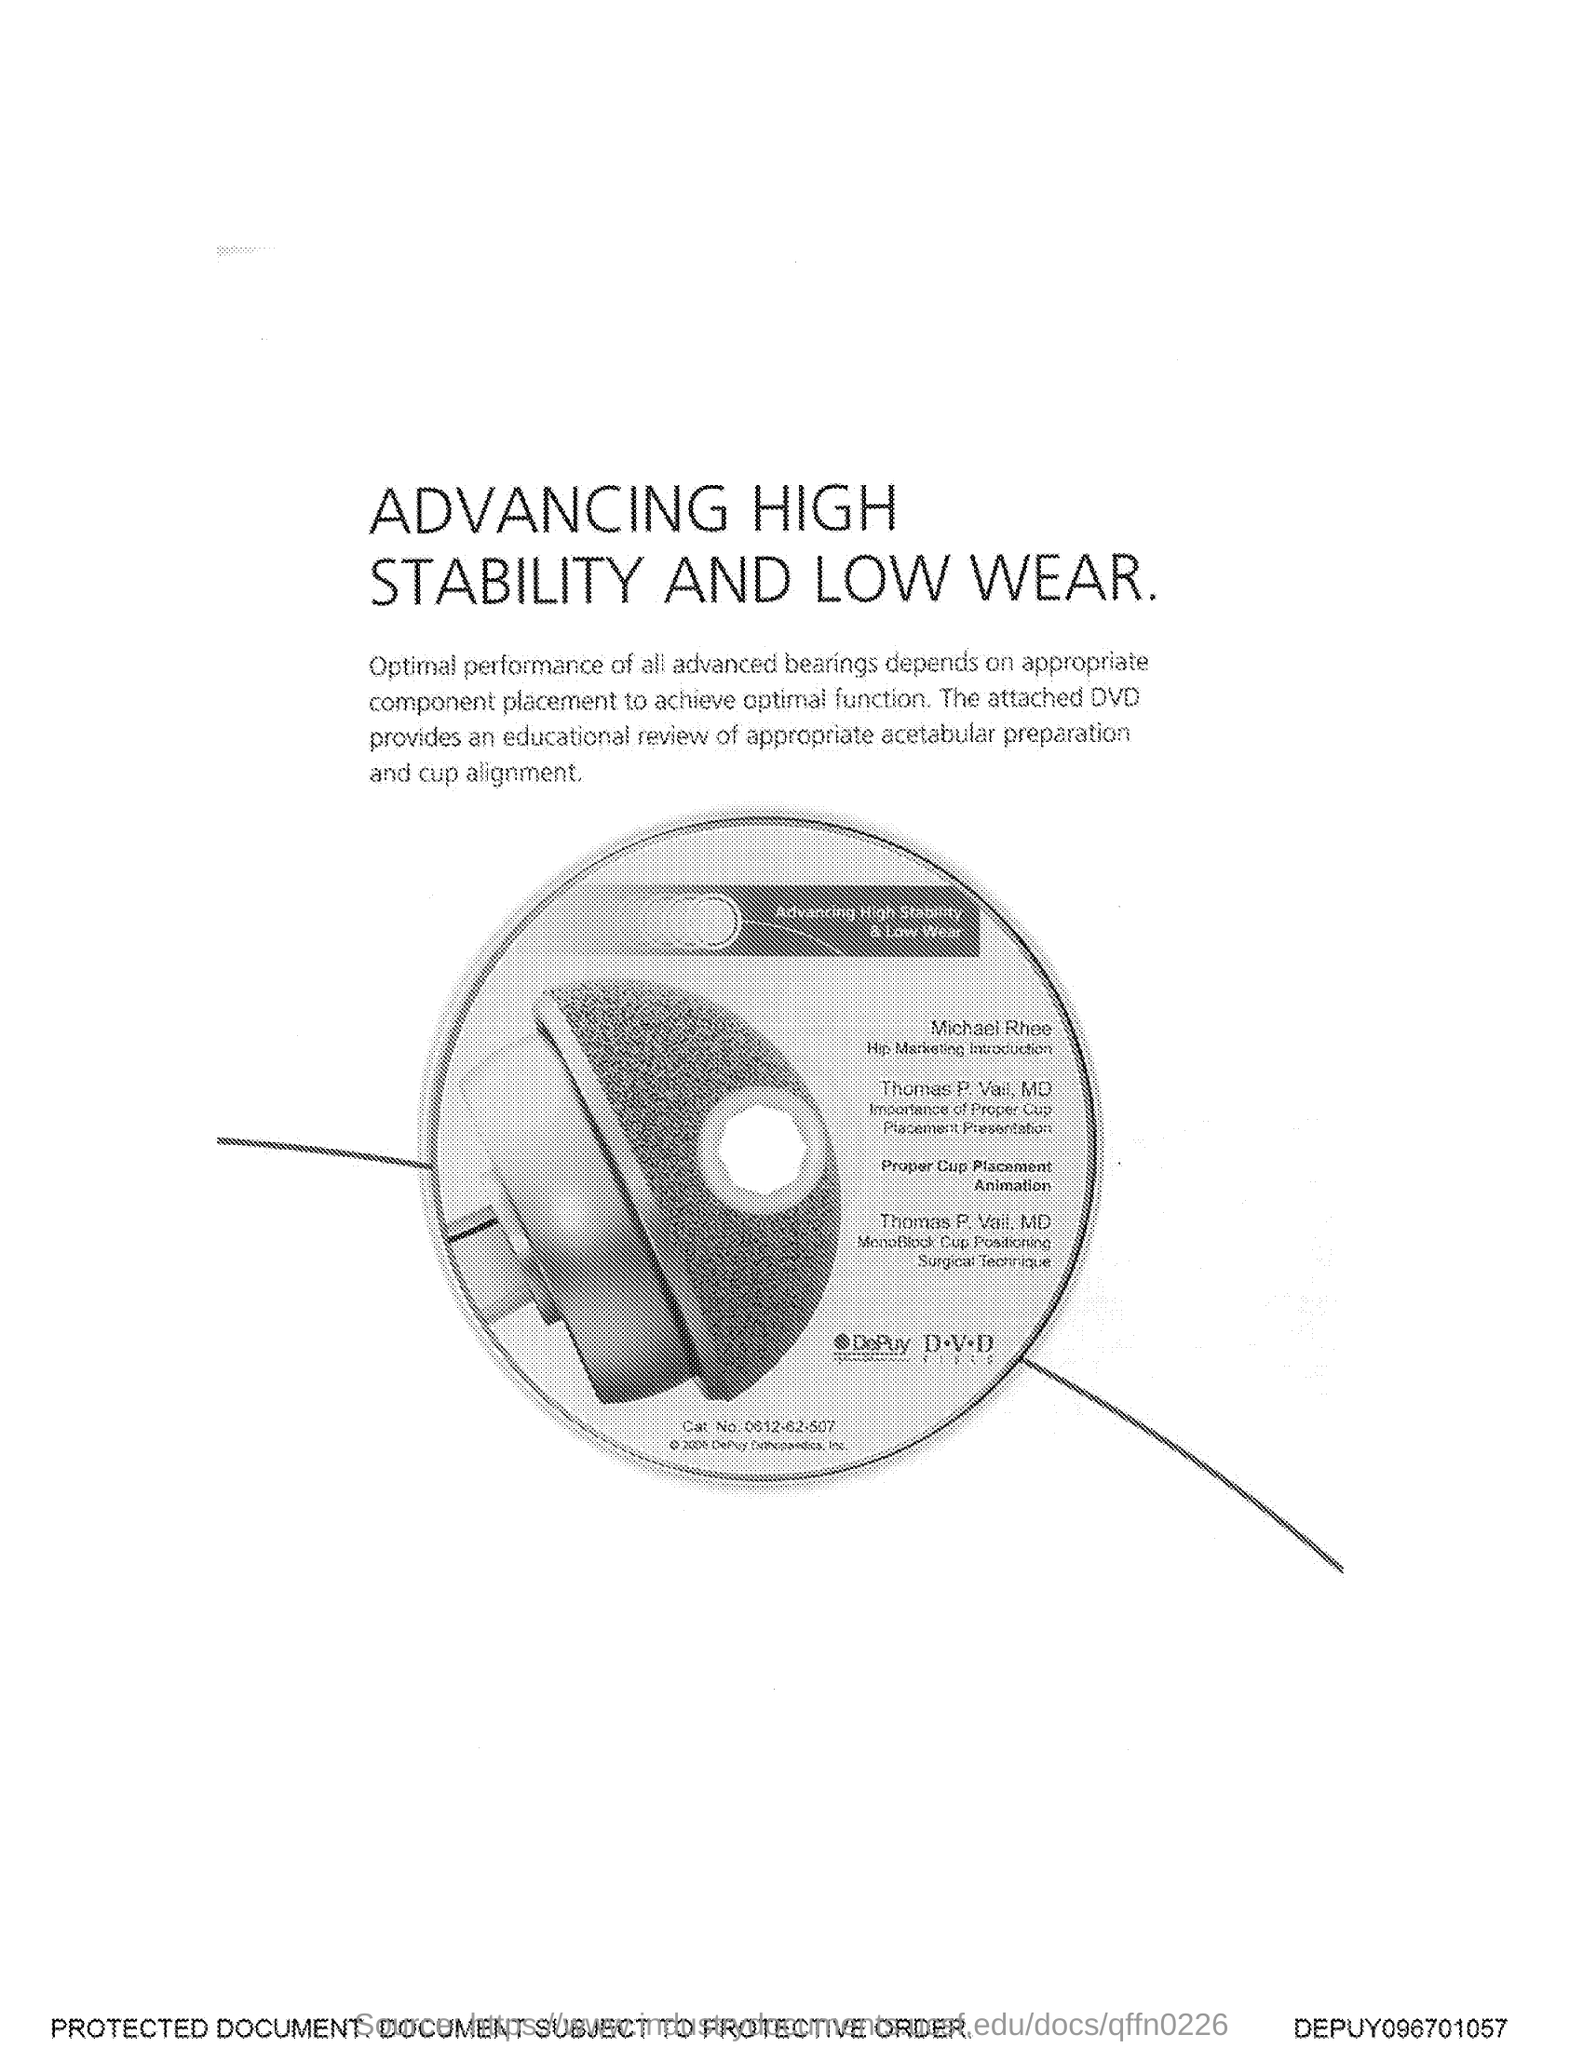Highlight a few significant elements in this photo. The title of the document is 'Advancing High Stability and Low Wear Rate of HDD'. 